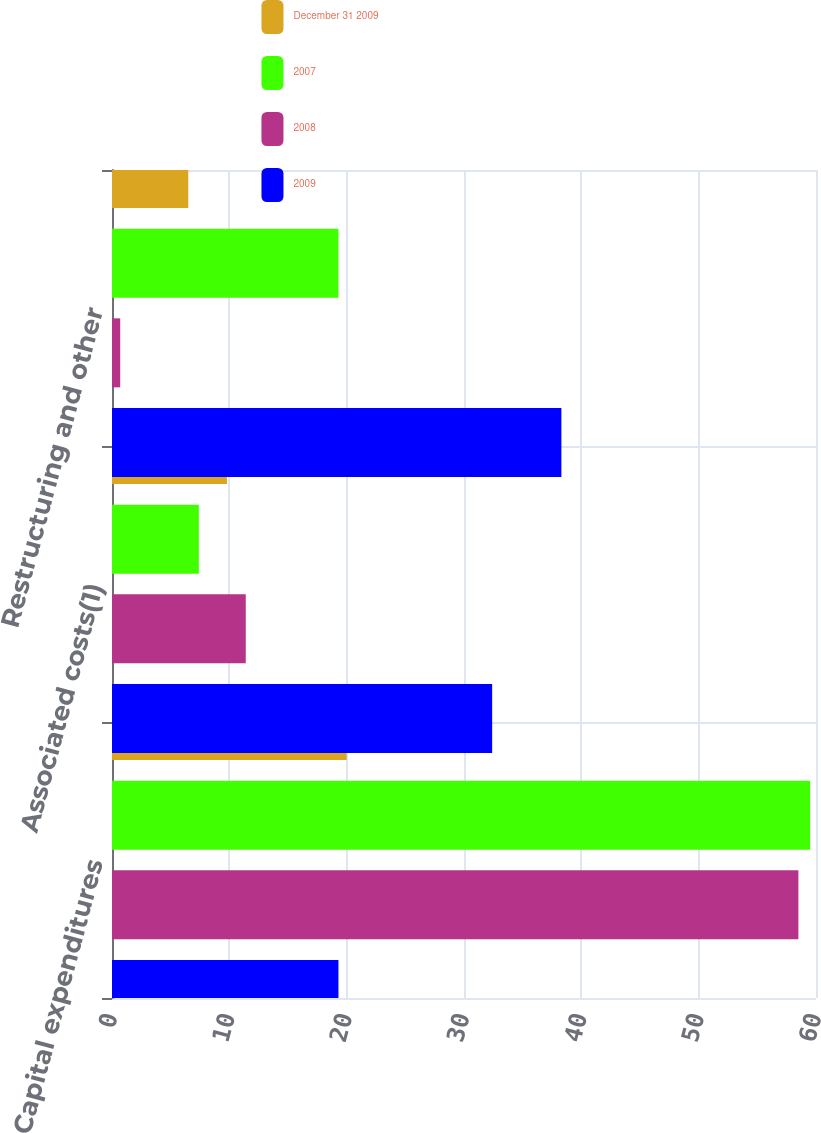Convert chart to OTSL. <chart><loc_0><loc_0><loc_500><loc_500><stacked_bar_chart><ecel><fcel>Capital expenditures<fcel>Associated costs(1)<fcel>Restructuring and other<nl><fcel>December 31 2009<fcel>20<fcel>9.8<fcel>6.5<nl><fcel>2007<fcel>59.5<fcel>7.4<fcel>19.3<nl><fcel>2008<fcel>58.5<fcel>11.4<fcel>0.7<nl><fcel>2009<fcel>19.3<fcel>32.4<fcel>38.3<nl></chart> 